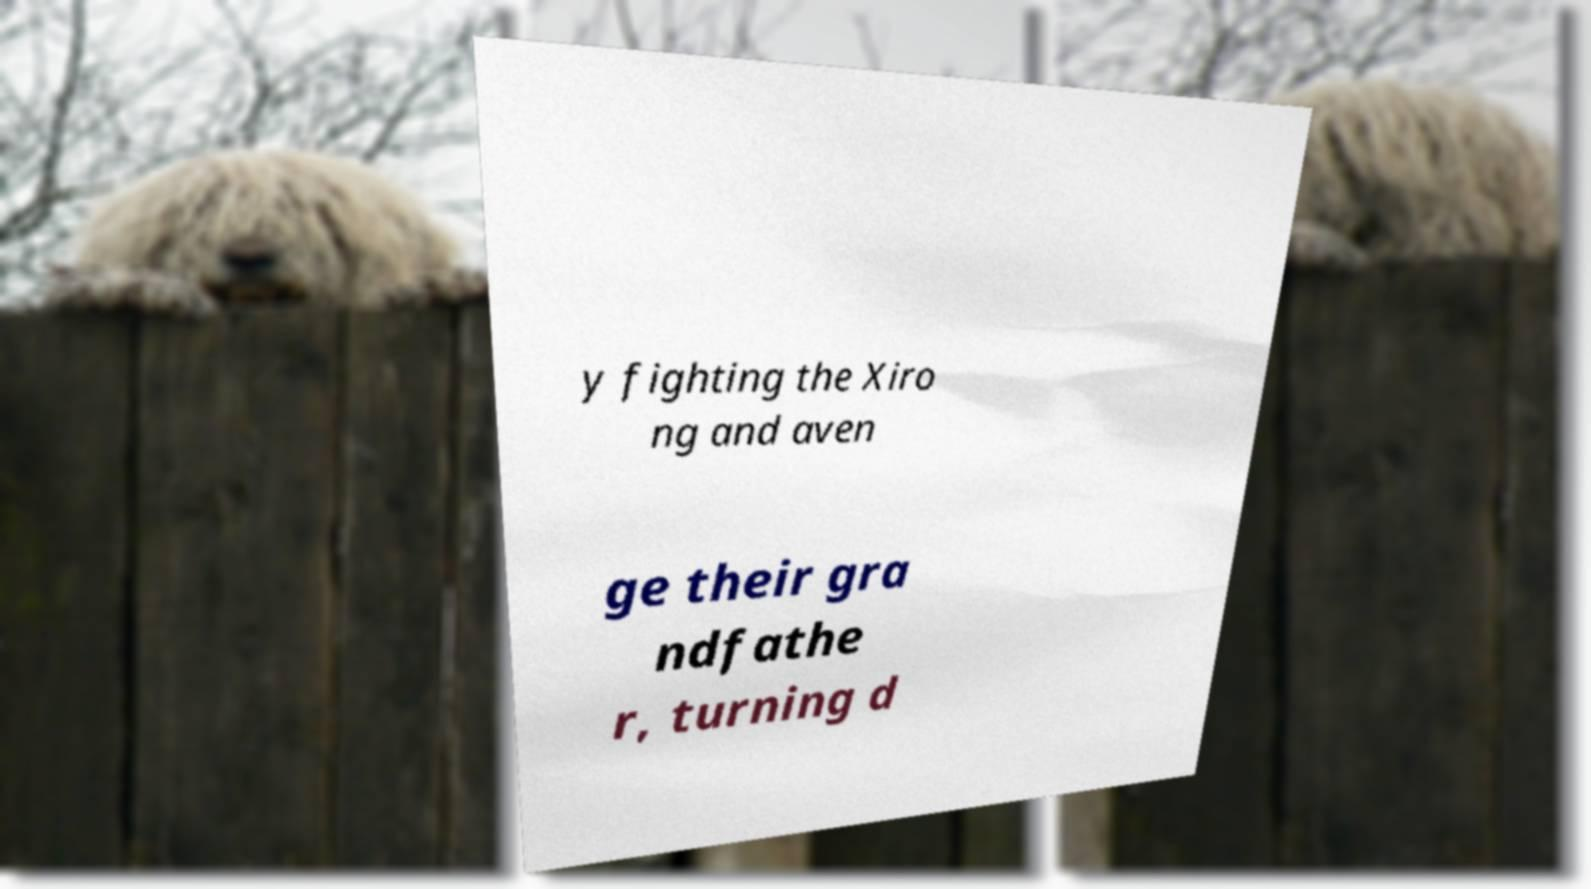For documentation purposes, I need the text within this image transcribed. Could you provide that? y fighting the Xiro ng and aven ge their gra ndfathe r, turning d 